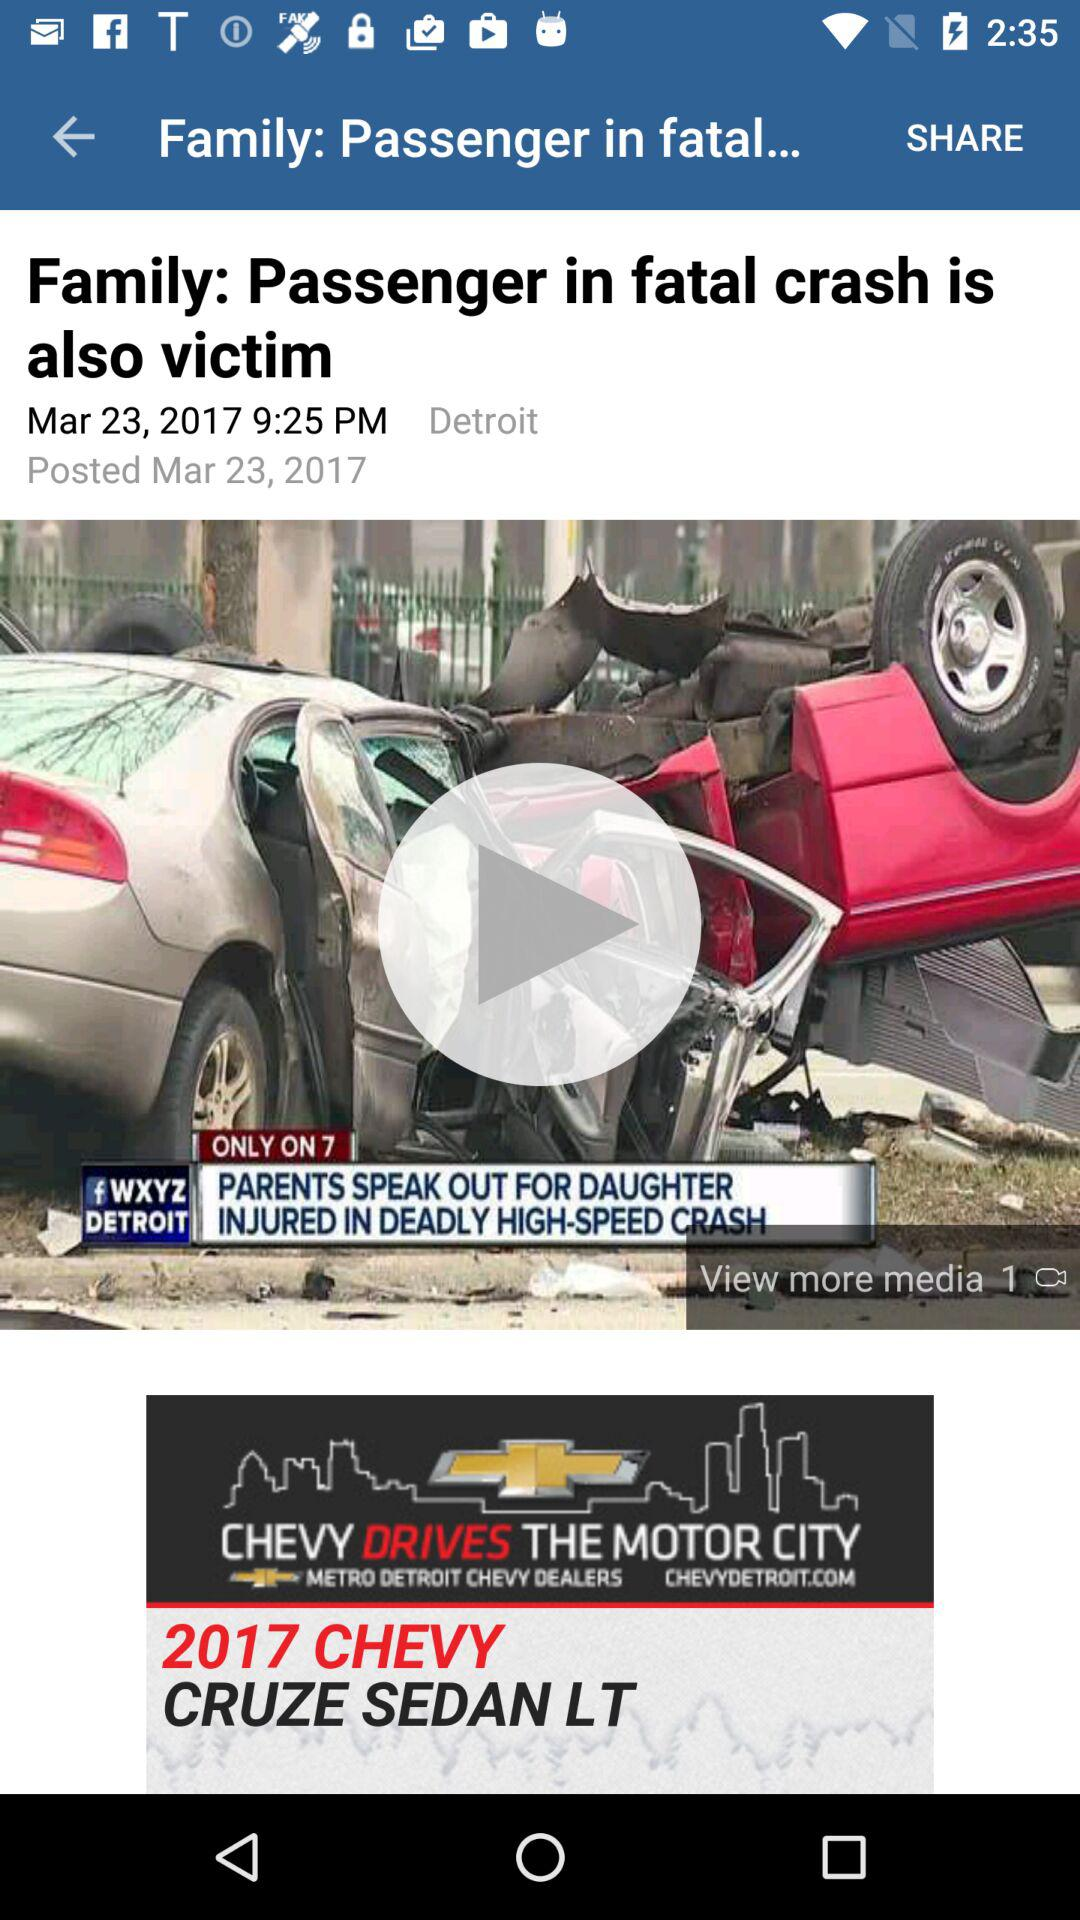What is the headline? The headline is "Family: Passenger in fatal crash is also victim". 